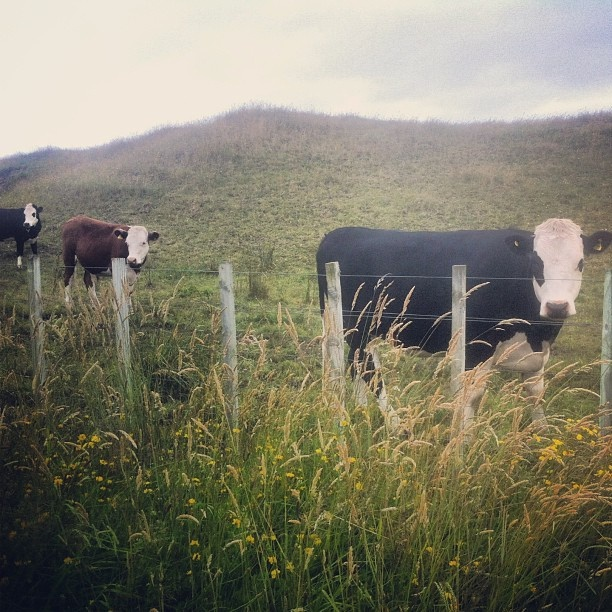Describe the objects in this image and their specific colors. I can see cow in ivory, gray, black, and tan tones, cow in ivory, black, gray, and darkgray tones, and cow in ivory, black, gray, and darkgray tones in this image. 